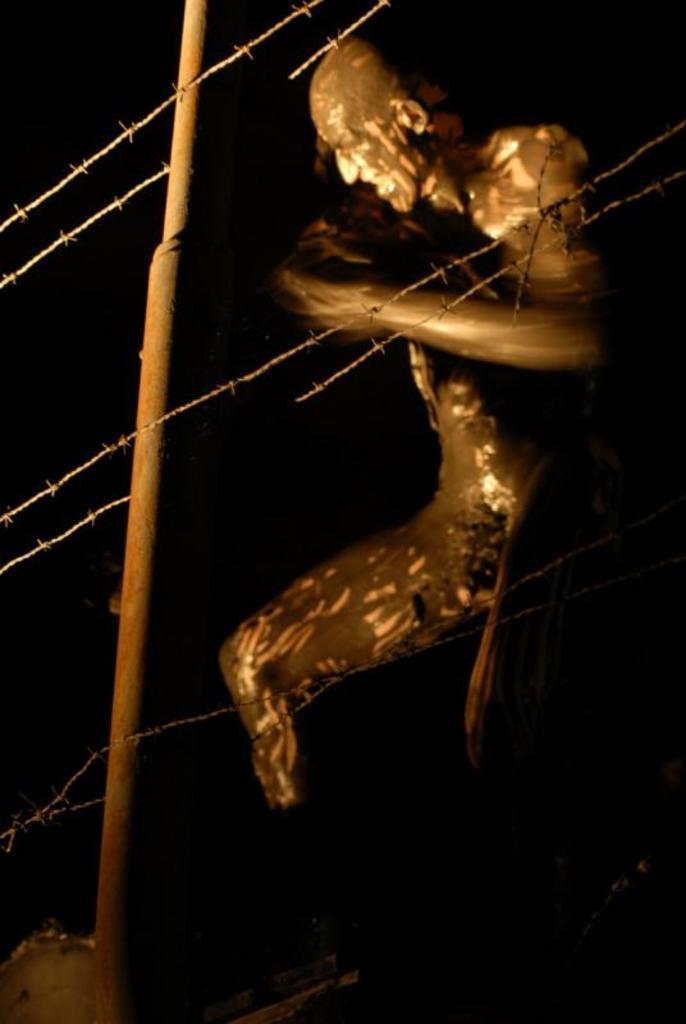Please provide a concise description of this image. In this image I can see the person with the mud. In-front of the person I can see the fence and the pole. And there is a black background. 